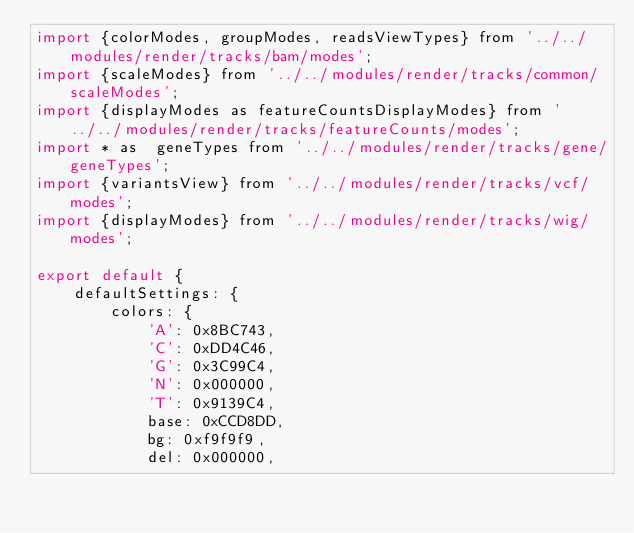Convert code to text. <code><loc_0><loc_0><loc_500><loc_500><_JavaScript_>import {colorModes, groupModes, readsViewTypes} from '../../modules/render/tracks/bam/modes';
import {scaleModes} from '../../modules/render/tracks/common/scaleModes';
import {displayModes as featureCountsDisplayModes} from '../../modules/render/tracks/featureCounts/modes';
import * as  geneTypes from '../../modules/render/tracks/gene/geneTypes';
import {variantsView} from '../../modules/render/tracks/vcf/modes';
import {displayModes} from '../../modules/render/tracks/wig/modes';

export default {
    defaultSettings: {
        colors: {
            'A': 0x8BC743,
            'C': 0xDD4C46,
            'G': 0x3C99C4,
            'N': 0x000000,
            'T': 0x9139C4,
            base: 0xCCD8DD,
            bg: 0xf9f9f9,
            del: 0x000000,</code> 